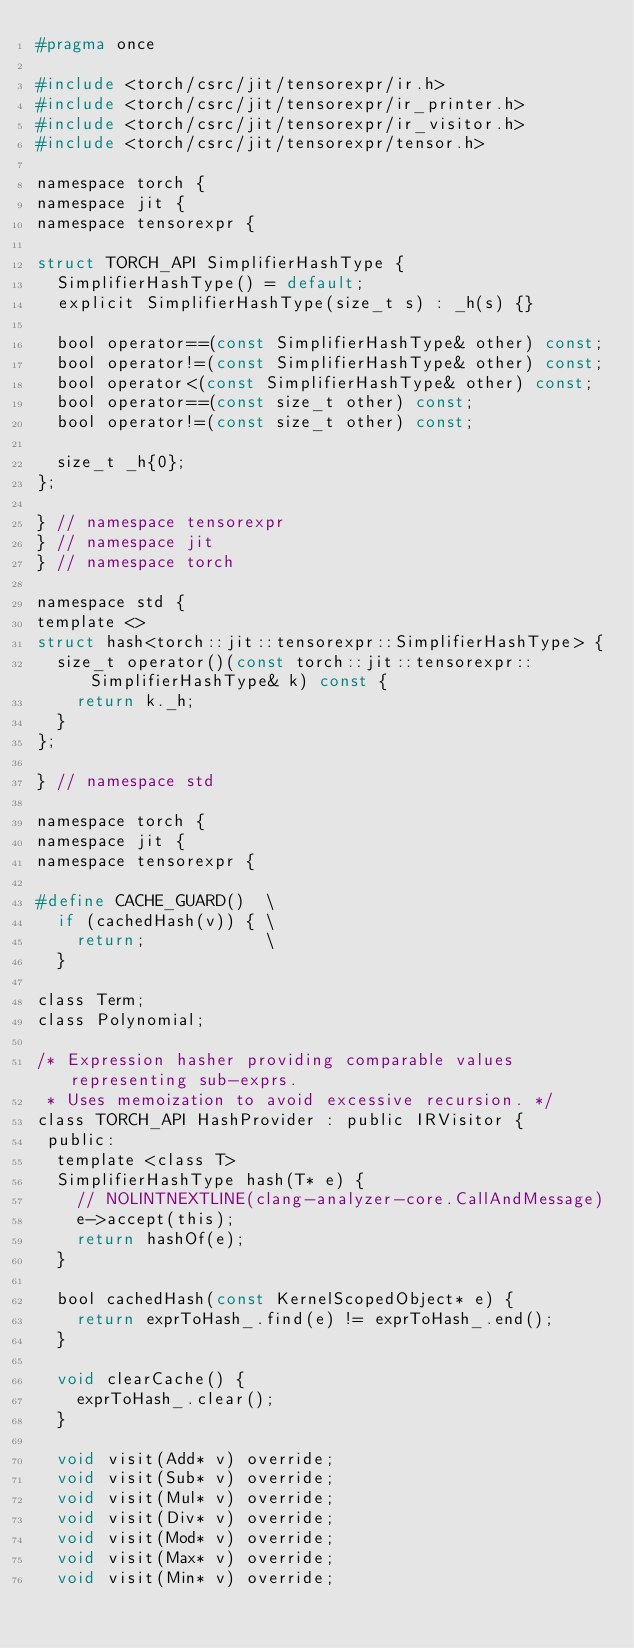Convert code to text. <code><loc_0><loc_0><loc_500><loc_500><_C_>#pragma once

#include <torch/csrc/jit/tensorexpr/ir.h>
#include <torch/csrc/jit/tensorexpr/ir_printer.h>
#include <torch/csrc/jit/tensorexpr/ir_visitor.h>
#include <torch/csrc/jit/tensorexpr/tensor.h>

namespace torch {
namespace jit {
namespace tensorexpr {

struct TORCH_API SimplifierHashType {
  SimplifierHashType() = default;
  explicit SimplifierHashType(size_t s) : _h(s) {}

  bool operator==(const SimplifierHashType& other) const;
  bool operator!=(const SimplifierHashType& other) const;
  bool operator<(const SimplifierHashType& other) const;
  bool operator==(const size_t other) const;
  bool operator!=(const size_t other) const;

  size_t _h{0};
};

} // namespace tensorexpr
} // namespace jit
} // namespace torch

namespace std {
template <>
struct hash<torch::jit::tensorexpr::SimplifierHashType> {
  size_t operator()(const torch::jit::tensorexpr::SimplifierHashType& k) const {
    return k._h;
  }
};

} // namespace std

namespace torch {
namespace jit {
namespace tensorexpr {

#define CACHE_GUARD()  \
  if (cachedHash(v)) { \
    return;            \
  }

class Term;
class Polynomial;

/* Expression hasher providing comparable values representing sub-exprs.
 * Uses memoization to avoid excessive recursion. */
class TORCH_API HashProvider : public IRVisitor {
 public:
  template <class T>
  SimplifierHashType hash(T* e) {
    // NOLINTNEXTLINE(clang-analyzer-core.CallAndMessage)
    e->accept(this);
    return hashOf(e);
  }

  bool cachedHash(const KernelScopedObject* e) {
    return exprToHash_.find(e) != exprToHash_.end();
  }

  void clearCache() {
    exprToHash_.clear();
  }

  void visit(Add* v) override;
  void visit(Sub* v) override;
  void visit(Mul* v) override;
  void visit(Div* v) override;
  void visit(Mod* v) override;
  void visit(Max* v) override;
  void visit(Min* v) override;</code> 